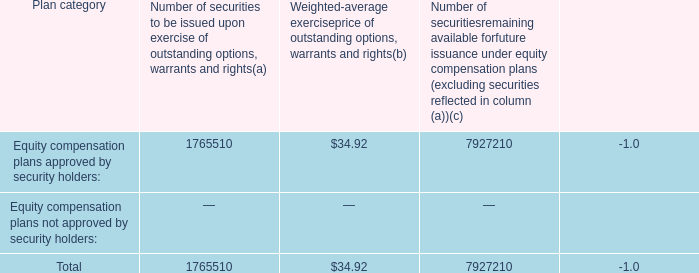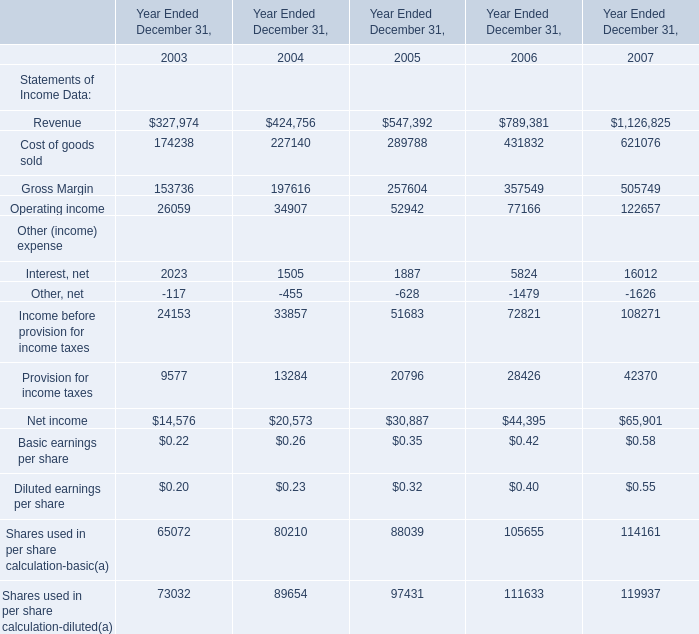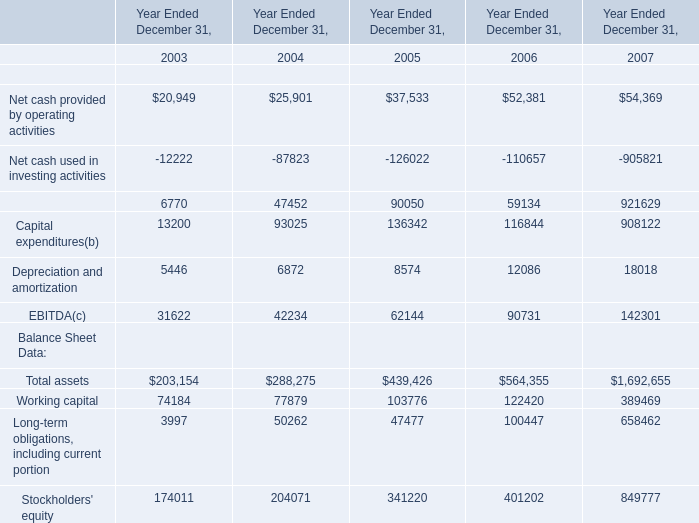What was the total amount of the Capital expenditures(b) in the years where Net cash provided by financing activities is greater than 70000? (in million) 
Computations: ((136342 + 116844) + 908122)
Answer: 1161308.0. 